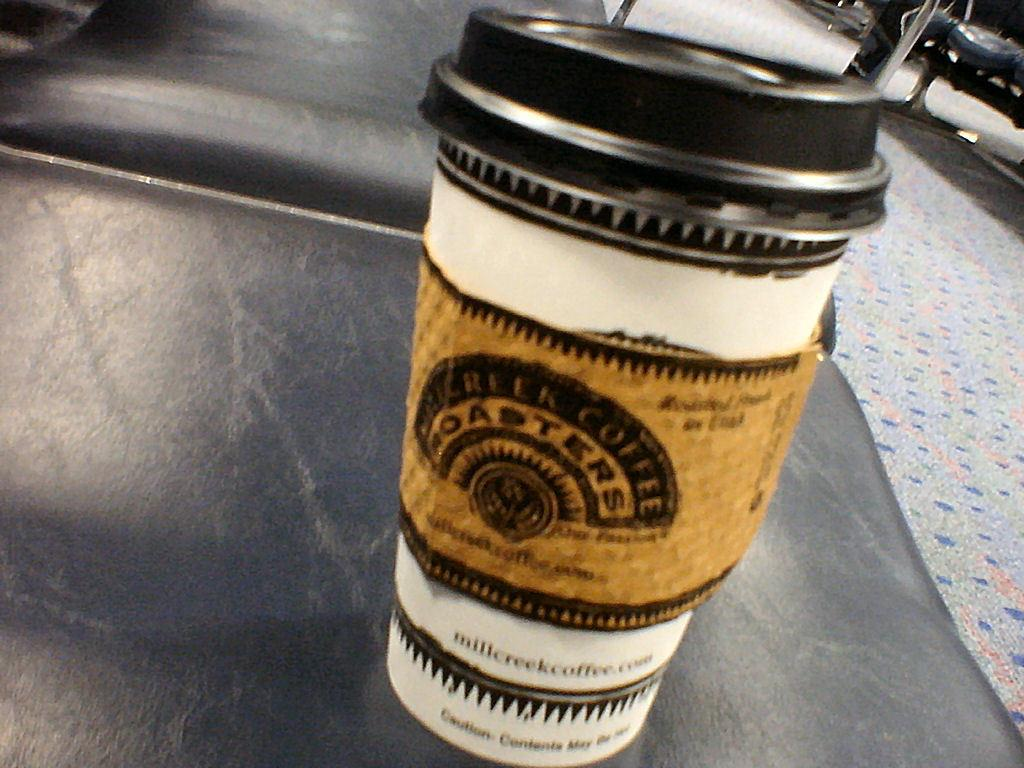<image>
Write a terse but informative summary of the picture. The coffee cup Coasters has a nice looking logo and design. 